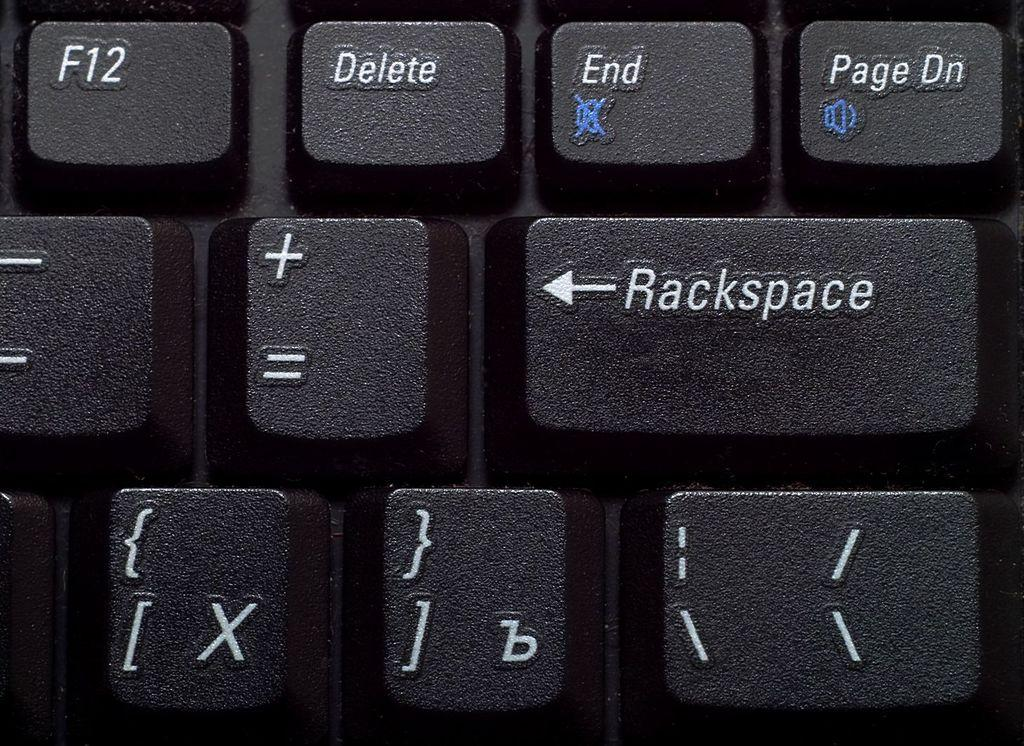Provide a one-sentence caption for the provided image. A close of of a keyboard with rackspace where it should say backspace. 